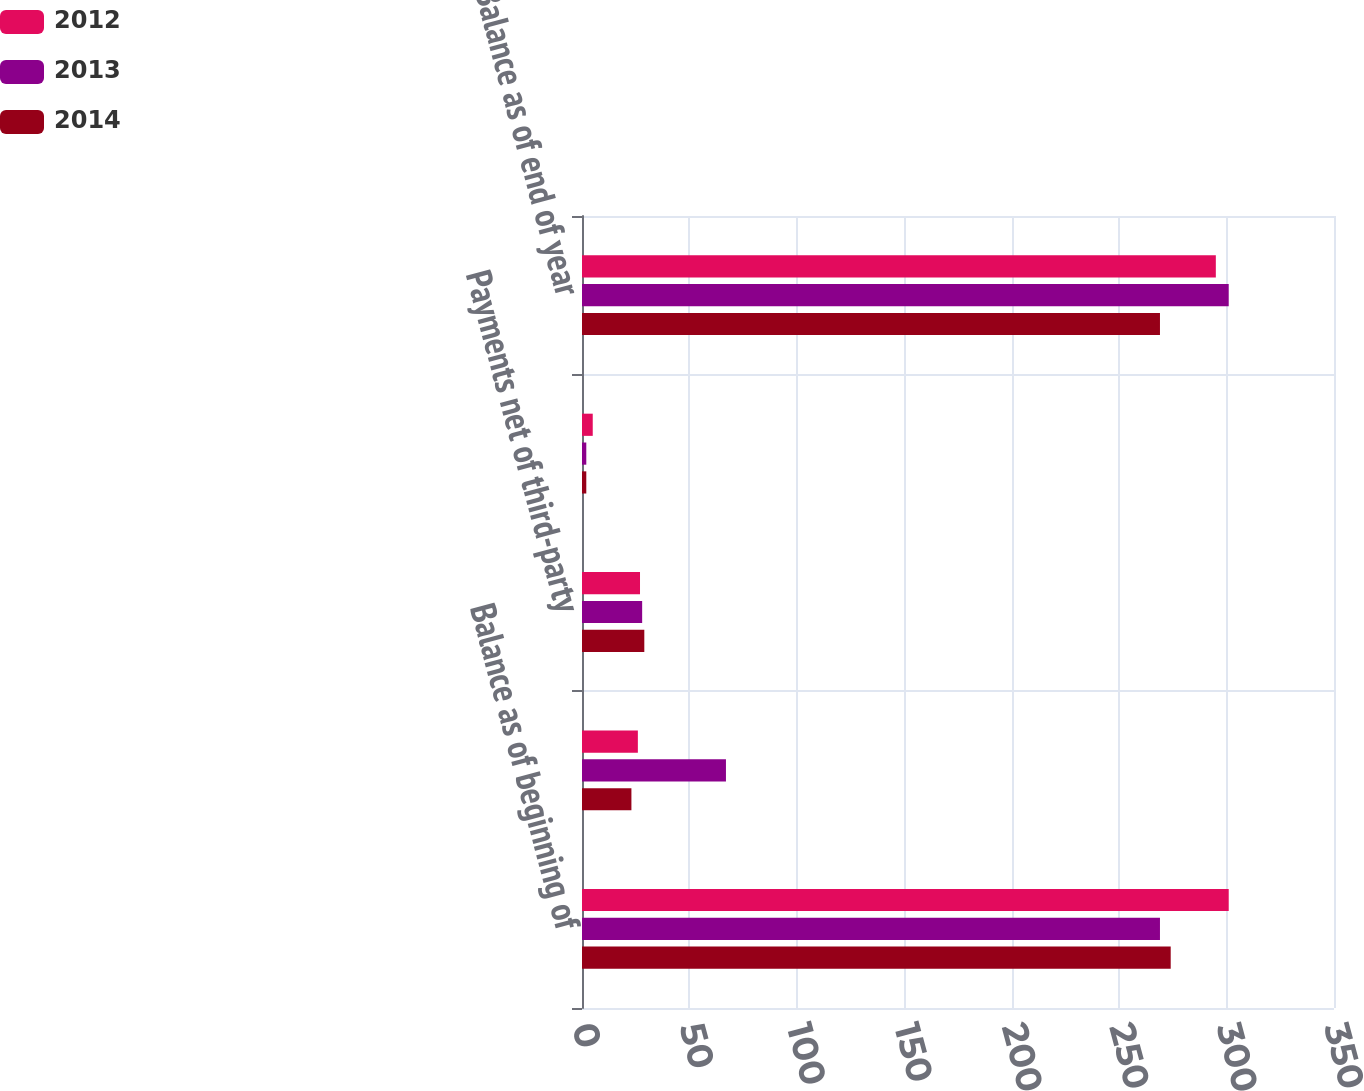<chart> <loc_0><loc_0><loc_500><loc_500><stacked_bar_chart><ecel><fcel>Balance as of beginning of<fcel>Additions to liability<fcel>Payments net of third-party<fcel>Foreign currency translation<fcel>Balance as of end of year<nl><fcel>2012<fcel>301<fcel>26<fcel>27<fcel>5<fcel>295<nl><fcel>2013<fcel>269<fcel>67<fcel>28<fcel>2<fcel>301<nl><fcel>2014<fcel>274<fcel>23<fcel>29<fcel>2<fcel>269<nl></chart> 